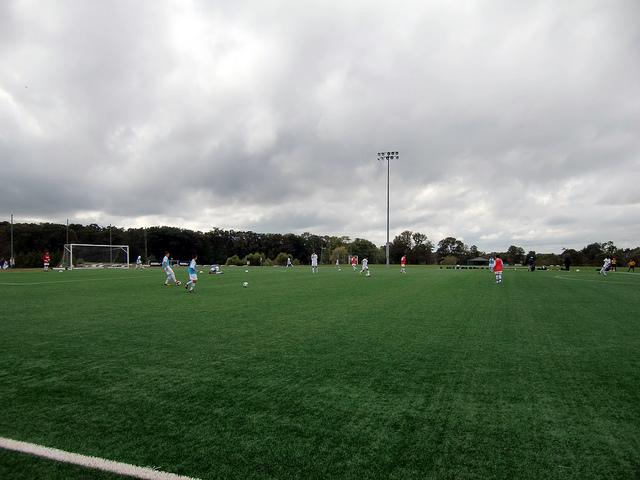Overcast or sunny?
Short answer required. Overcast. These boys are getting to play what game?
Be succinct. Soccer. What kind of weather it is?
Answer briefly. Cloudy. Are we behind a fence?
Write a very short answer. No. What color is the sky?
Give a very brief answer. Gray. Is that net used for tennis?
Write a very short answer. No. Does this field need mowing?
Quick response, please. No. How many batters do you see?
Concise answer only. 0. What's the weather like in the picture?
Concise answer only. Cloudy. Does the fake grass match the trees?
Concise answer only. No. What sport is being played?
Keep it brief. Soccer. Could it begin raining?
Keep it brief. Yes. 